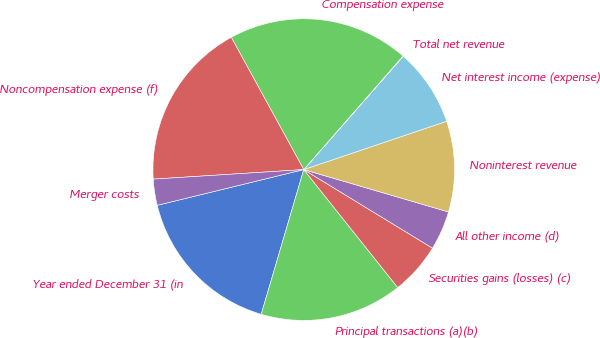<chart> <loc_0><loc_0><loc_500><loc_500><pie_chart><fcel>Year ended December 31 (in<fcel>Principal transactions (a)(b)<fcel>Securities gains (losses) (c)<fcel>All other income (d)<fcel>Noninterest revenue<fcel>Net interest income (expense)<fcel>Total net revenue<fcel>Compensation expense<fcel>Noncompensation expense (f)<fcel>Merger costs<nl><fcel>16.64%<fcel>15.26%<fcel>5.57%<fcel>4.19%<fcel>9.72%<fcel>8.34%<fcel>0.04%<fcel>19.41%<fcel>18.03%<fcel>2.8%<nl></chart> 